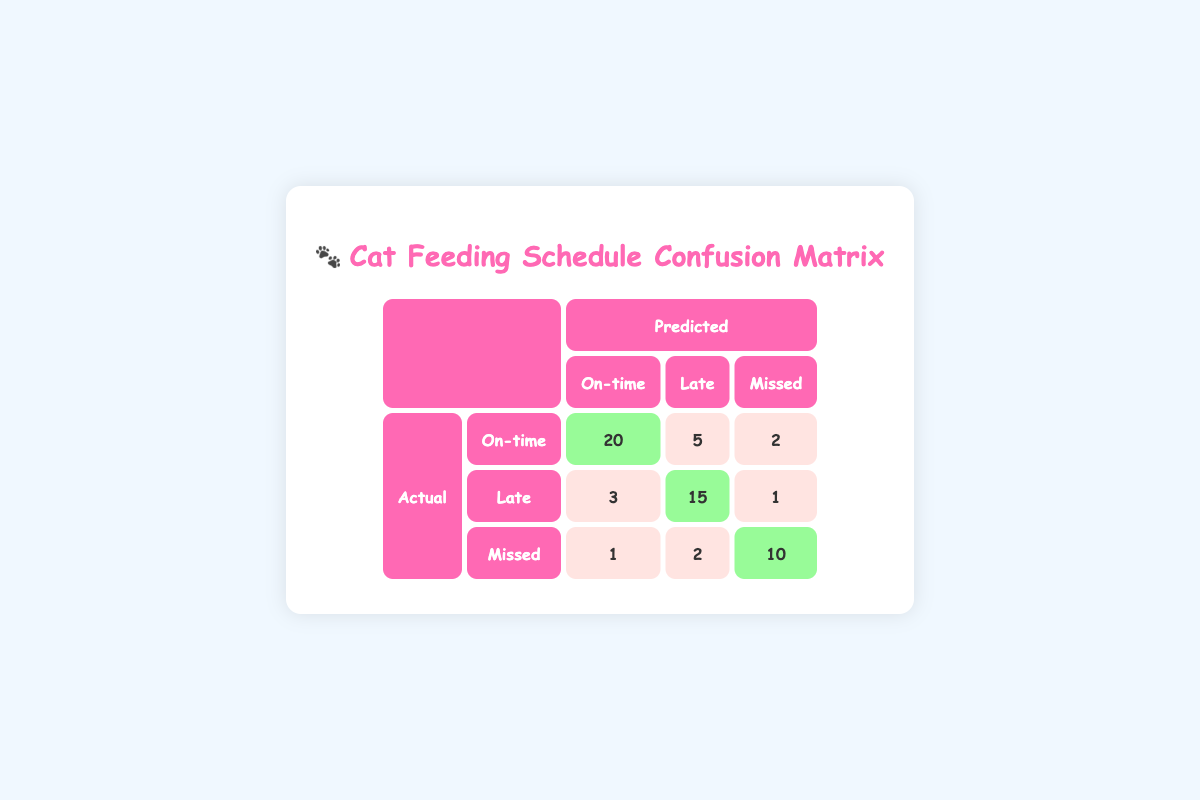What is the number of times the feeding was on-time? In the table, under the 'On-time' actual feeding category, the highlighted value shows there were 20 instances where the feeding was predicted as on-time.
Answer: 20 How many times was the feeding predicted as late? To find this, we look at the 'Late' column for all actual categories. The counts are 5 (from 'On-time'), 15 (from 'Late'), and 2 (from 'Missed'). Summing these: 5 + 15 + 2 = 22.
Answer: 22 Was the feeding ever missed when it was actually on-time? Looking at the 'On-time' actual category, the predicted 'Missed' count is 2. This means there were 2 instances when feeding was missed even though it was due on-time.
Answer: Yes What is the total number of feeding instances that were missed? We consider the 'Missed' row of the actual feeding categories, where the counts are 1 (predicted On-time), 2 (predicted Late), and 10 (predicted Missed). Totaling these values gives us: 1 + 2 + 10 = 13 instances missed.
Answer: 13 How many predictions were made on-time when feeding was actually missed? In the 'Missed' actual category, the predicted count for 'On-time' is 1, indicating that there was 1 instance where the feeding was predicted to be on-time despite being missed.
Answer: 1 What percentage of on-time feedings were accurately predicted? The total number of 'On-time' actual feedings is 20 (predicted as On-time) plus 5 (predicted as Late) plus 2 (predicted as Missed) = 27. The percentage of on-time feedings predicted correctly is (20/27) * 100 ≈ 74.07%.
Answer: 74.07% What is the total count of feedings predicted as missed? Summing the predicted 'Missed' values yields: 2 (from 'On-time'), 1 (from 'Late'), and 10 (from 'Missed'), totaling 2 + 1 + 10 = 13 feedings predicted as missed.
Answer: 13 How many late feedings were incorrectly predicted as on-time? Checking the actual 'Late' category, the predicted count for 'On-time' is 3, reflecting 3 instances where feedings that were actually late were incorrectly predicted as on-time.
Answer: 3 What is the difference in count between the predicted 'Late' and 'Missed' feedings for actual feedings? For each actual category, the counts are: For 'On-time' it's 5 (Late) and 2 (Missed), difference is 5 - 2 = 3. For 'Late', it's 15 (Late) and 1 (Missed), giving 15 - 1 = 14. For 'Missed', it's 2 (Late) and 10 (Missed), resulting in 2 - 10 = -8. Summing these gives a total difference of 3 + 14 - 8 = 9.
Answer: 9 